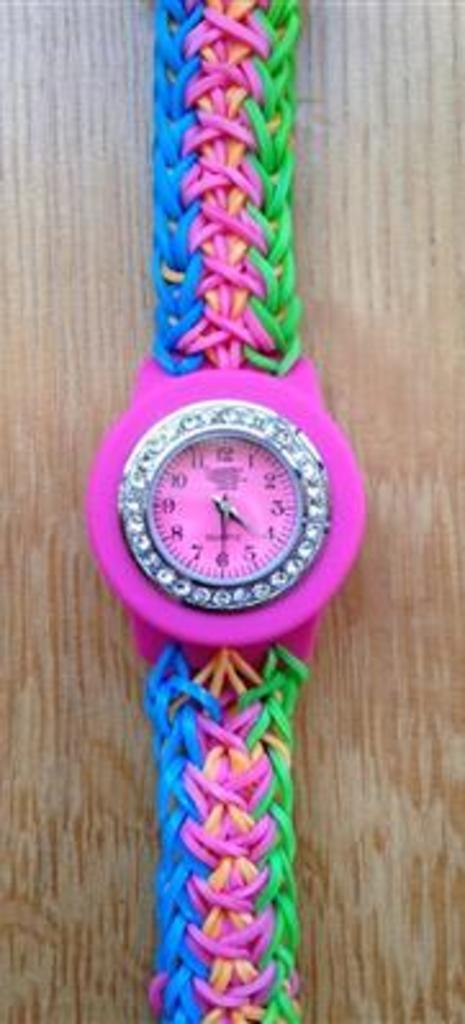<image>
Offer a succinct explanation of the picture presented. Pink watch with the hands on numbers 4 and 6. 